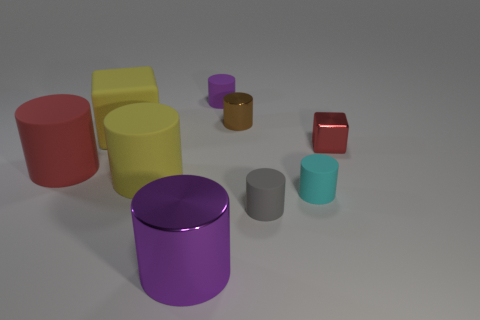What is the size of the shiny thing in front of the tiny metallic block?
Give a very brief answer. Large. How many large things are either cyan matte cylinders or purple rubber spheres?
Offer a terse response. 0. What color is the matte cylinder that is both right of the yellow block and on the left side of the purple matte cylinder?
Keep it short and to the point. Yellow. Are there any red objects of the same shape as the tiny purple object?
Your response must be concise. Yes. What material is the large purple thing?
Offer a terse response. Metal. Are there any shiny objects on the right side of the small cyan rubber cylinder?
Give a very brief answer. Yes. Is the gray rubber object the same shape as the large red thing?
Your answer should be very brief. Yes. How many other things are there of the same size as the red cube?
Your answer should be compact. 4. How many things are tiny matte things that are right of the gray rubber thing or tiny brown metal objects?
Offer a terse response. 2. What color is the tiny shiny block?
Offer a very short reply. Red. 